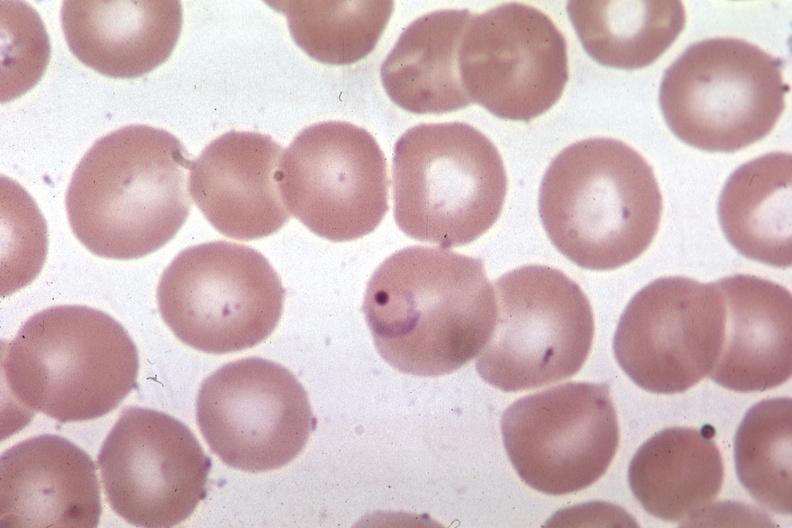what is present?
Answer the question using a single word or phrase. Malaria plasmodium vivax 